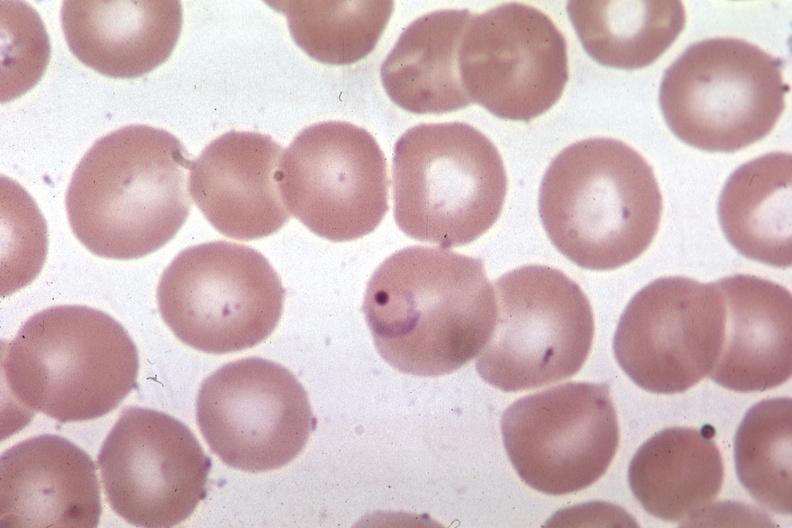what is present?
Answer the question using a single word or phrase. Malaria plasmodium vivax 